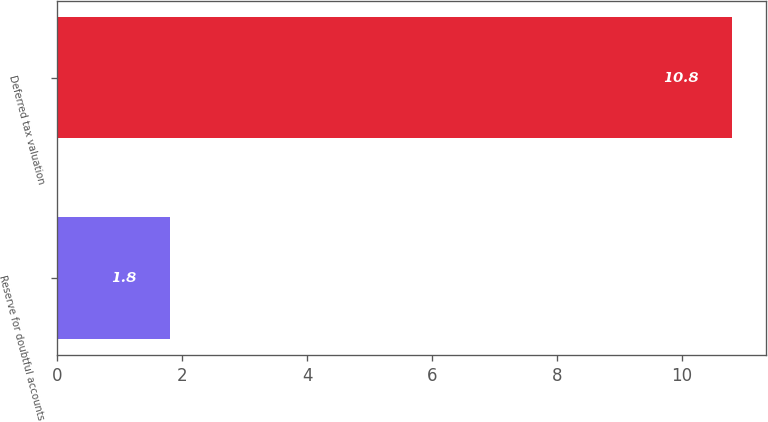<chart> <loc_0><loc_0><loc_500><loc_500><bar_chart><fcel>Reserve for doubtful accounts<fcel>Deferred tax valuation<nl><fcel>1.8<fcel>10.8<nl></chart> 